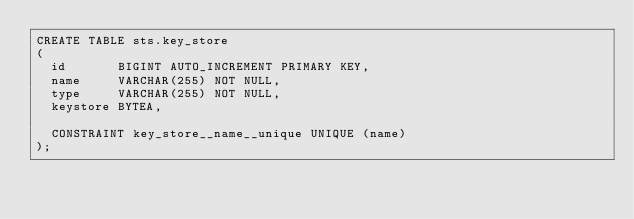<code> <loc_0><loc_0><loc_500><loc_500><_SQL_>CREATE TABLE sts.key_store
(
  id       BIGINT AUTO_INCREMENT PRIMARY KEY,
  name     VARCHAR(255) NOT NULL,
  type     VARCHAR(255) NOT NULL,
  keystore BYTEA,

  CONSTRAINT key_store__name__unique UNIQUE (name)
);
</code> 